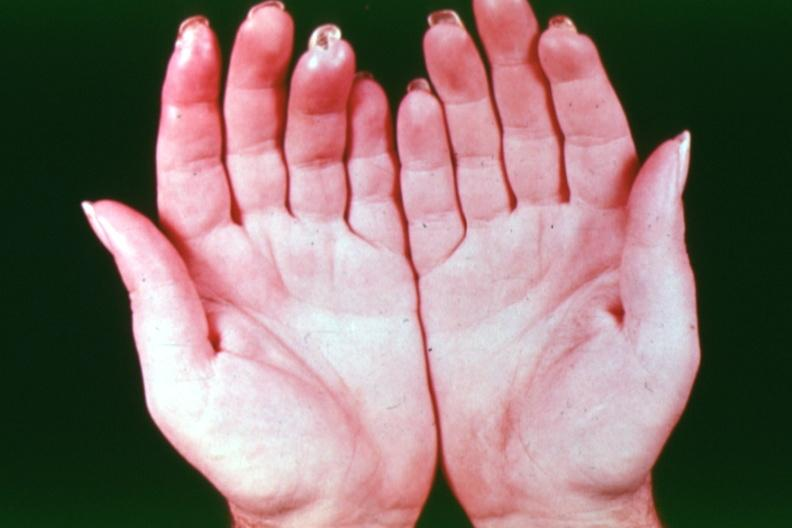what are present?
Answer the question using a single word or phrase. Extremities 